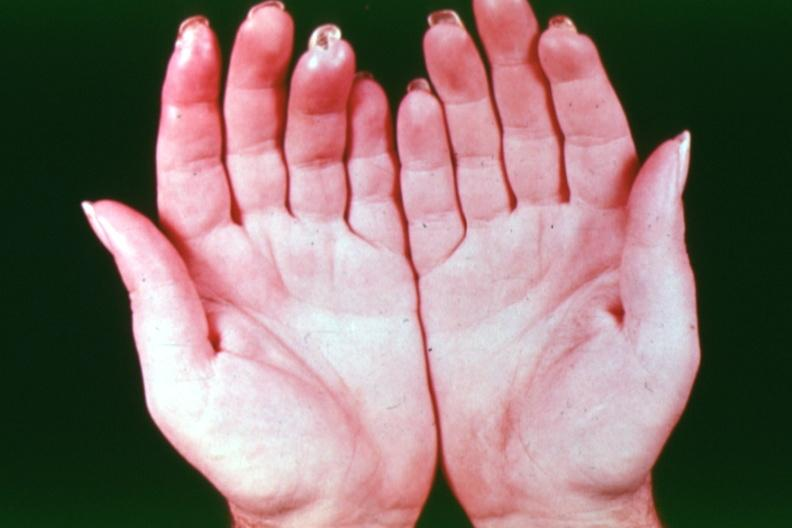what are present?
Answer the question using a single word or phrase. Extremities 